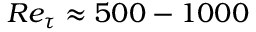Convert formula to latex. <formula><loc_0><loc_0><loc_500><loc_500>R e _ { \tau } \approx 5 0 0 - 1 0 0 0</formula> 